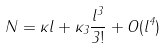<formula> <loc_0><loc_0><loc_500><loc_500>N = \kappa l + \kappa _ { 3 } \frac { l ^ { 3 } } { 3 ! } + O ( l ^ { 4 } )</formula> 